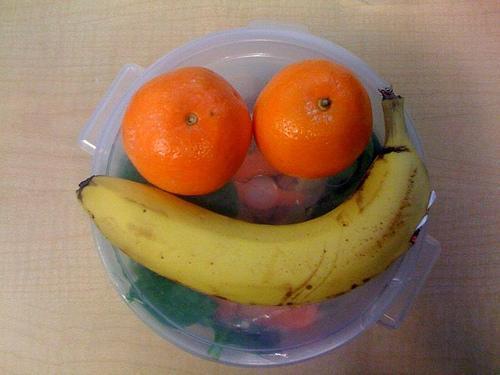How many different types of fruits are on the plate?
Give a very brief answer. 2. How many oranges are there?
Give a very brief answer. 2. How many people are using a cell phone in the image?
Give a very brief answer. 0. 